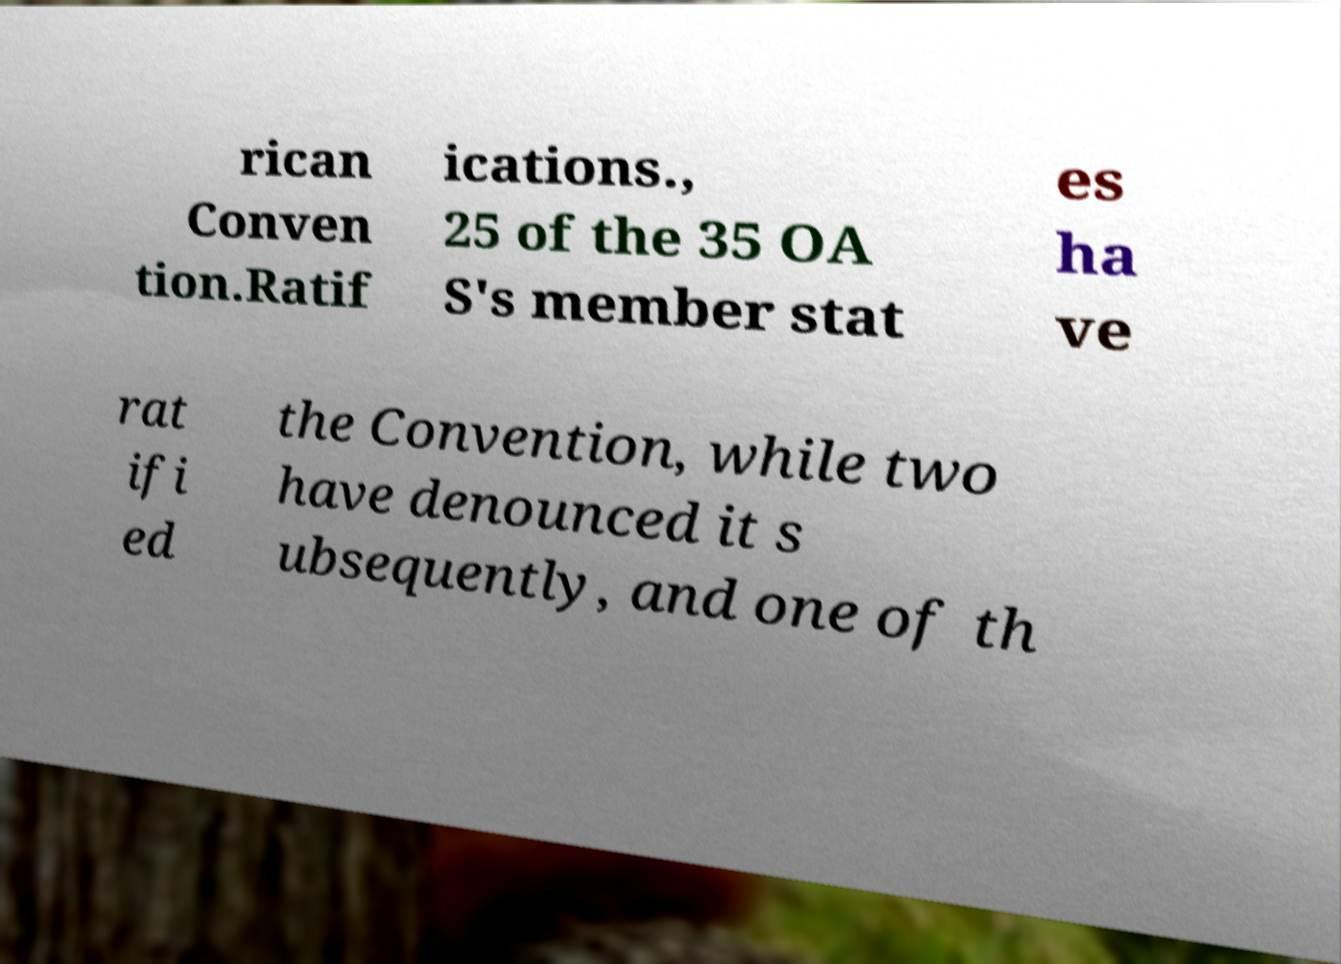What messages or text are displayed in this image? I need them in a readable, typed format. rican Conven tion.Ratif ications., 25 of the 35 OA S's member stat es ha ve rat ifi ed the Convention, while two have denounced it s ubsequently, and one of th 